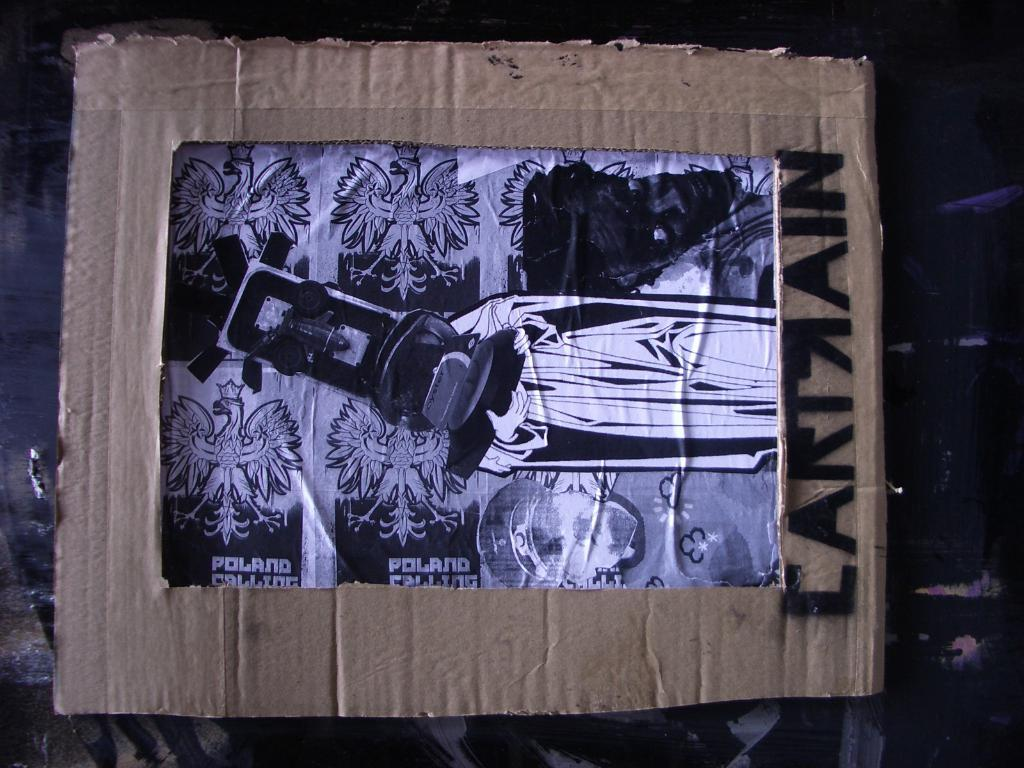What is the main object in the image? There is a cardboard sheet in the image. What is attached to the cardboard sheet? There is a poster on the cardboard sheet. What can be seen on the poster? The poster contains an image of a person holding an object with their hands. Are there any other objects depicted on the poster? Yes, the poster also contains other objects. What type of spot can be seen on the person's shirt in the image? There is no person visible in the image, only a poster with an image of a person holding an object with their hands. 